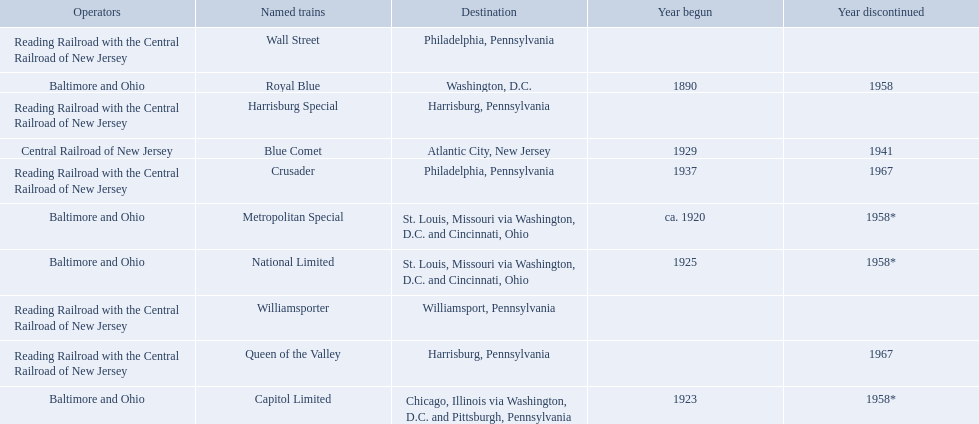Which operators are the reading railroad with the central railroad of new jersey? Reading Railroad with the Central Railroad of New Jersey, Reading Railroad with the Central Railroad of New Jersey, Reading Railroad with the Central Railroad of New Jersey, Reading Railroad with the Central Railroad of New Jersey, Reading Railroad with the Central Railroad of New Jersey. Which destinations are philadelphia, pennsylvania? Philadelphia, Pennsylvania, Philadelphia, Pennsylvania. What on began in 1937? 1937. What is the named train? Crusader. 